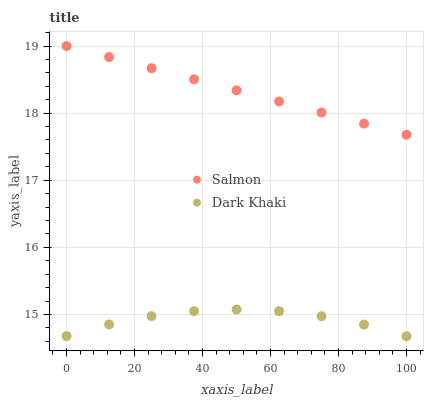Does Dark Khaki have the minimum area under the curve?
Answer yes or no. Yes. Does Salmon have the maximum area under the curve?
Answer yes or no. Yes. Does Salmon have the minimum area under the curve?
Answer yes or no. No. Is Salmon the smoothest?
Answer yes or no. Yes. Is Dark Khaki the roughest?
Answer yes or no. Yes. Is Salmon the roughest?
Answer yes or no. No. Does Dark Khaki have the lowest value?
Answer yes or no. Yes. Does Salmon have the lowest value?
Answer yes or no. No. Does Salmon have the highest value?
Answer yes or no. Yes. Is Dark Khaki less than Salmon?
Answer yes or no. Yes. Is Salmon greater than Dark Khaki?
Answer yes or no. Yes. Does Dark Khaki intersect Salmon?
Answer yes or no. No. 